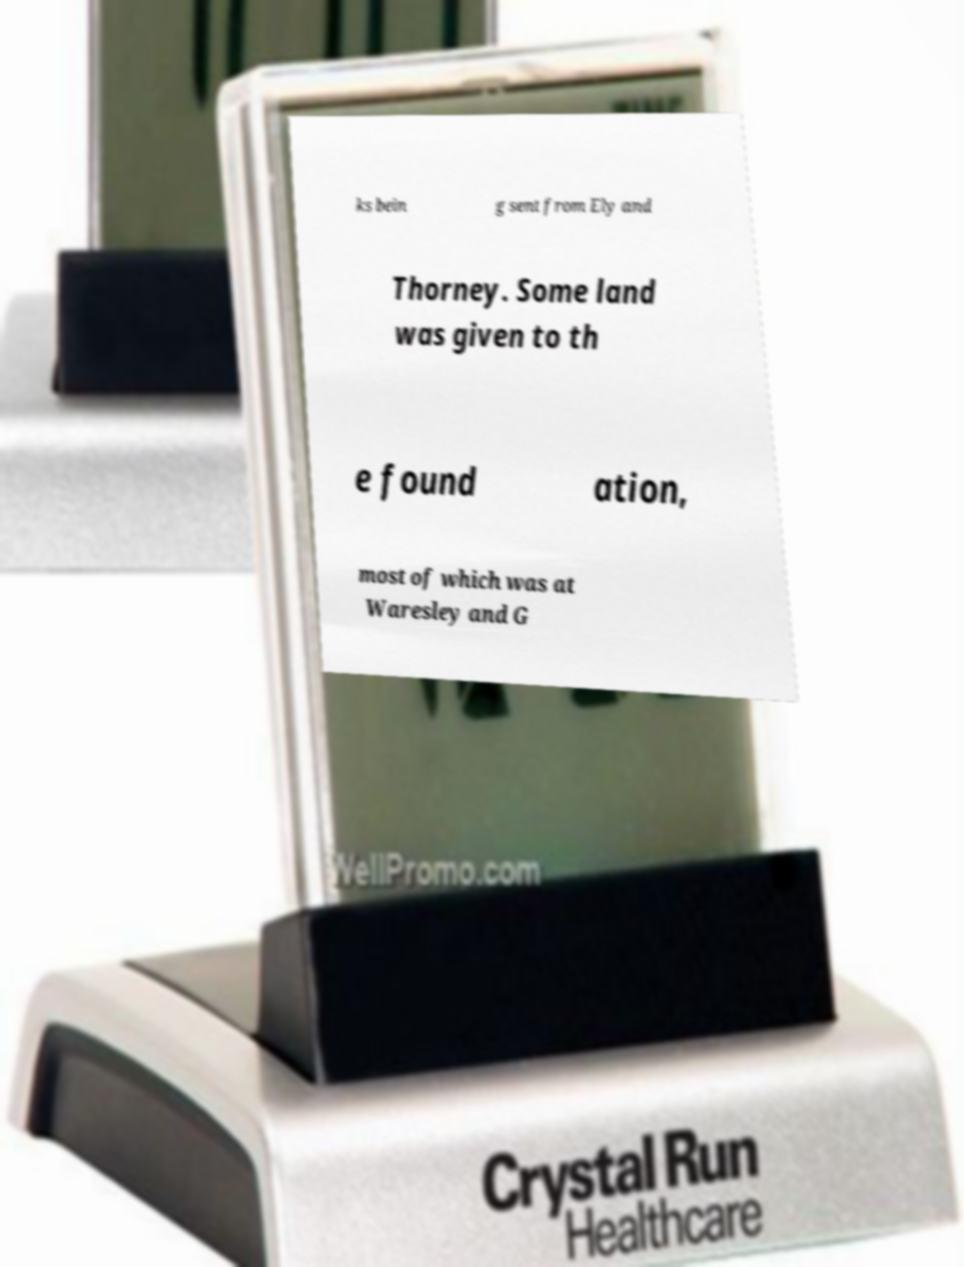Can you read and provide the text displayed in the image?This photo seems to have some interesting text. Can you extract and type it out for me? ks bein g sent from Ely and Thorney. Some land was given to th e found ation, most of which was at Waresley and G 